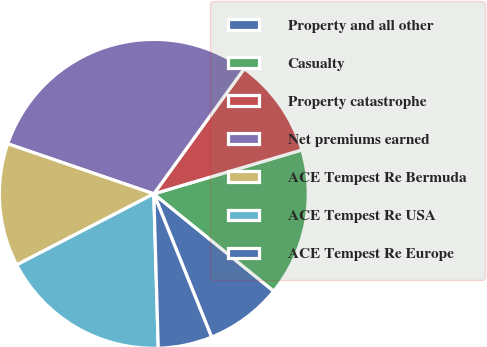Convert chart. <chart><loc_0><loc_0><loc_500><loc_500><pie_chart><fcel>Property and all other<fcel>Casualty<fcel>Property catastrophe<fcel>Net premiums earned<fcel>ACE Tempest Re Bermuda<fcel>ACE Tempest Re USA<fcel>ACE Tempest Re Europe<nl><fcel>8.05%<fcel>15.44%<fcel>10.45%<fcel>29.7%<fcel>12.86%<fcel>17.85%<fcel>5.64%<nl></chart> 